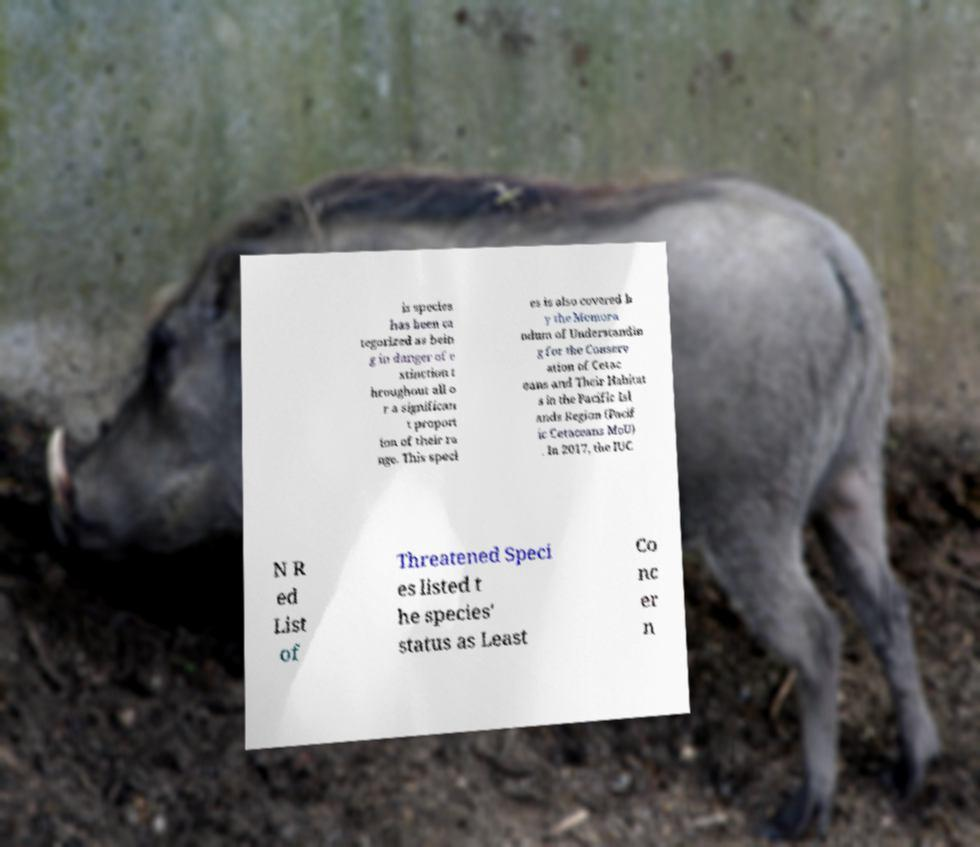Could you extract and type out the text from this image? is species has been ca tegorized as bein g in danger of e xtinction t hroughout all o r a significan t proport ion of their ra nge. This speci es is also covered b y the Memora ndum of Understandin g for the Conserv ation of Cetac eans and Their Habitat s in the Pacific Isl ands Region (Pacif ic Cetaceans MoU) . In 2017, the IUC N R ed List of Threatened Speci es listed t he species' status as Least Co nc er n 